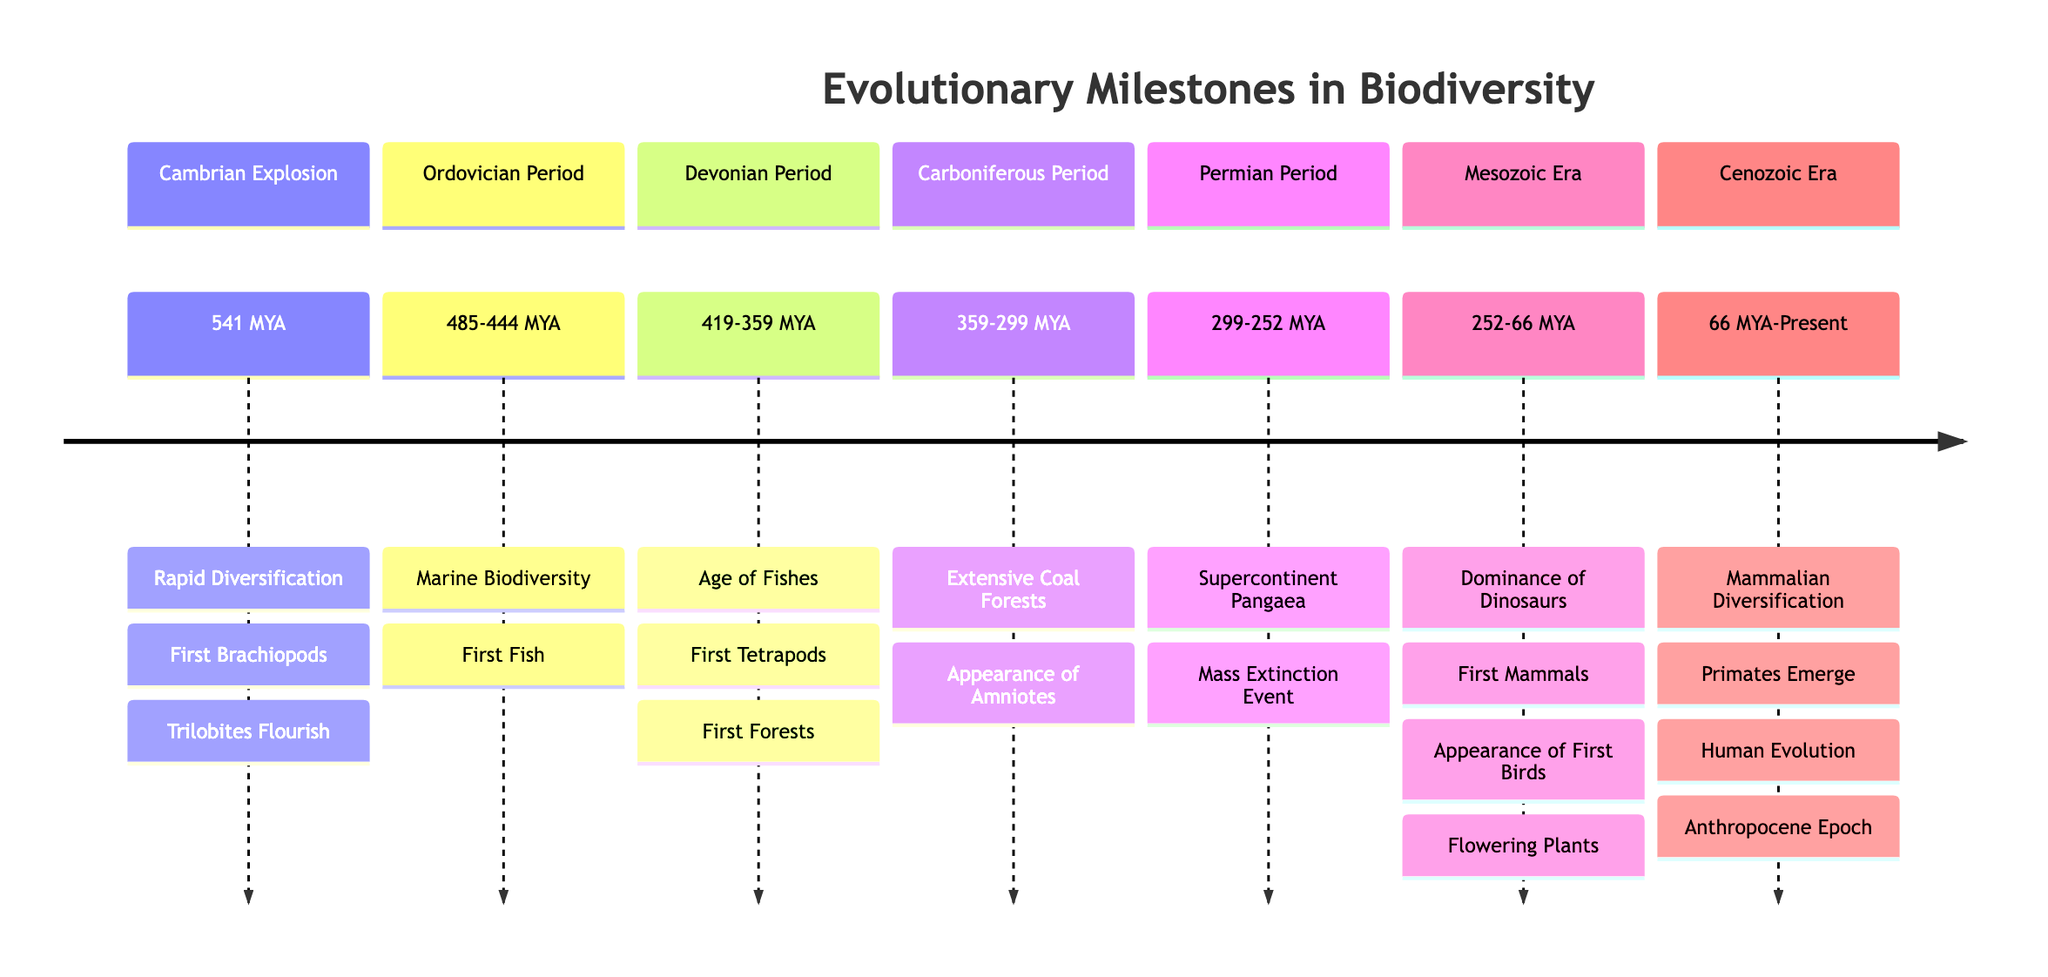What key event marks the beginning of the Cambrian Explosion? The diagram identifies "Rapid Diversification" as the primary event during the Cambrian Explosion. This information is located in the Cambrian Explosion section at the top of the timeline.
Answer: Rapid Diversification What significant event occurred in the Ordovician Period? The diagram lists "Marine Biodiversity" as a key event in the Ordovician Period. This information is found in the Ordovician Period section, indicating a notable increase in marine life.
Answer: Marine Biodiversity Which group of animals first appeared during the Devonian Period? According to the diagram, "First Tetrapods" are identified as a key event in the Devonian Period. This shows that tetrapods were the first vertebrates to move onto land.
Answer: First Tetrapods How long did the Mesozoic Era last? The diagram shows the Mesozoic Era timeframe as "252 to 66 million years ago." This indicates the duration of this era spans from 252 million years ago to 66 million years ago.
Answer: 252 to 66 million years ago What major transition occurred during the Carboniferous Period? The appearance of "Amniotes" is a highlighted event in the Carboniferous Period. This indicates a significant advancement in reproductive strategies compared to earlier vertebrates.
Answer: Appearance of Amniotes Which event represents the largest mass extinction in Earth's history? The diagram references "Mass Extinction Event" in the Permian Period section, noting it resulted in the extinction of about 90% of marine and 70% of terrestrial species.
Answer: Mass Extinction Event What characterized the Cenozoic Era following the extinction of dinosaurs? The diagram states "Mammalian Diversification" occurred in the Cenozoic Era, illustrating the rise of mammals following this major extinction event.
Answer: Mammalian Diversification How many key events are listed for the Mesozoic Era? The Mesozoic Era section of the diagram lists four significant events: Dominance of Dinosaurs, First Mammals, Appearance of First Birds, and Flowering Plants, indicating a high diversity during this era.
Answer: 4 Which period first saw the appearance of coral reefs? The diagram indicates that coral reefs emerged in the "Marine Biodiversity" event during the Ordovician Period, thus marking their early development in the fossil record.
Answer: Ordovician Period 